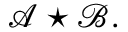Convert formula to latex. <formula><loc_0><loc_0><loc_500><loc_500>{ \mathcal { A } } ^ { * } { \mathcal { B } } .</formula> 